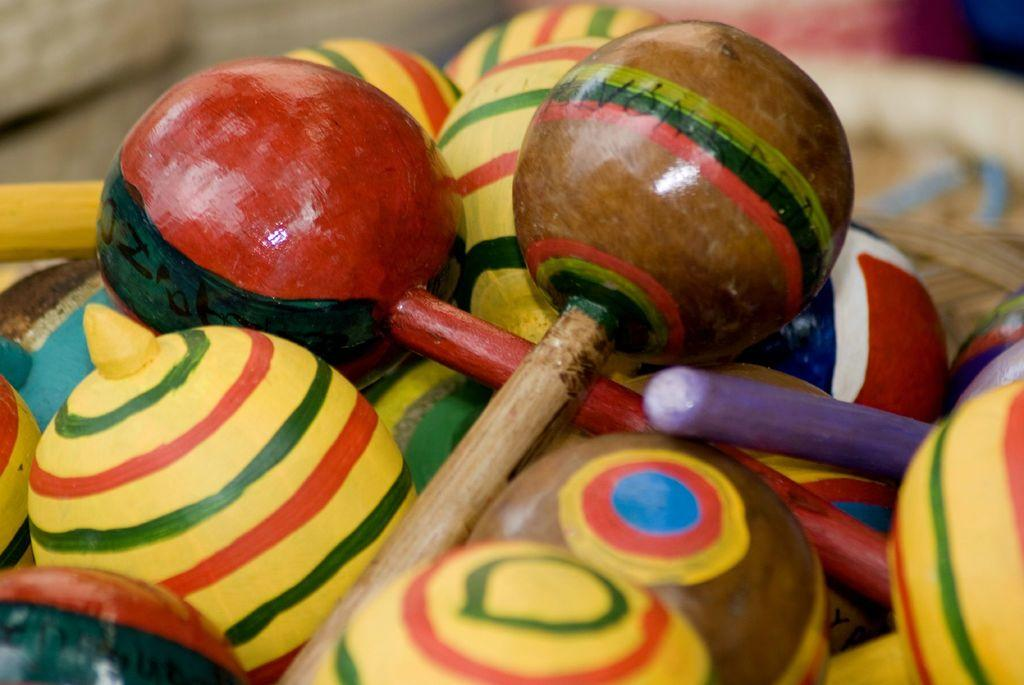What type of toys are present in the image? There are wooden toys in the image. What attempt was made to power the wooden toys in the image? There is no attempt to power the wooden toys in the image, as they are likely traditional, non-electronic toys. 